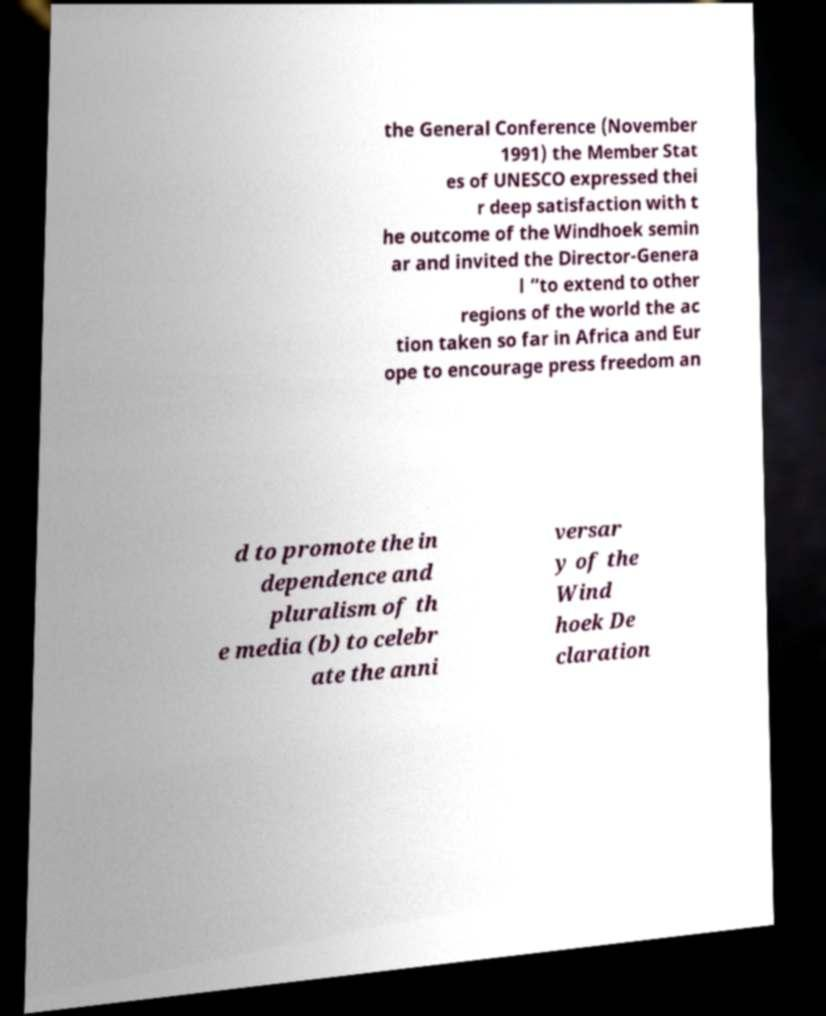Can you accurately transcribe the text from the provided image for me? the General Conference (November 1991) the Member Stat es of UNESCO expressed thei r deep satisfaction with t he outcome of the Windhoek semin ar and invited the Director-Genera l “to extend to other regions of the world the ac tion taken so far in Africa and Eur ope to encourage press freedom an d to promote the in dependence and pluralism of th e media (b) to celebr ate the anni versar y of the Wind hoek De claration 